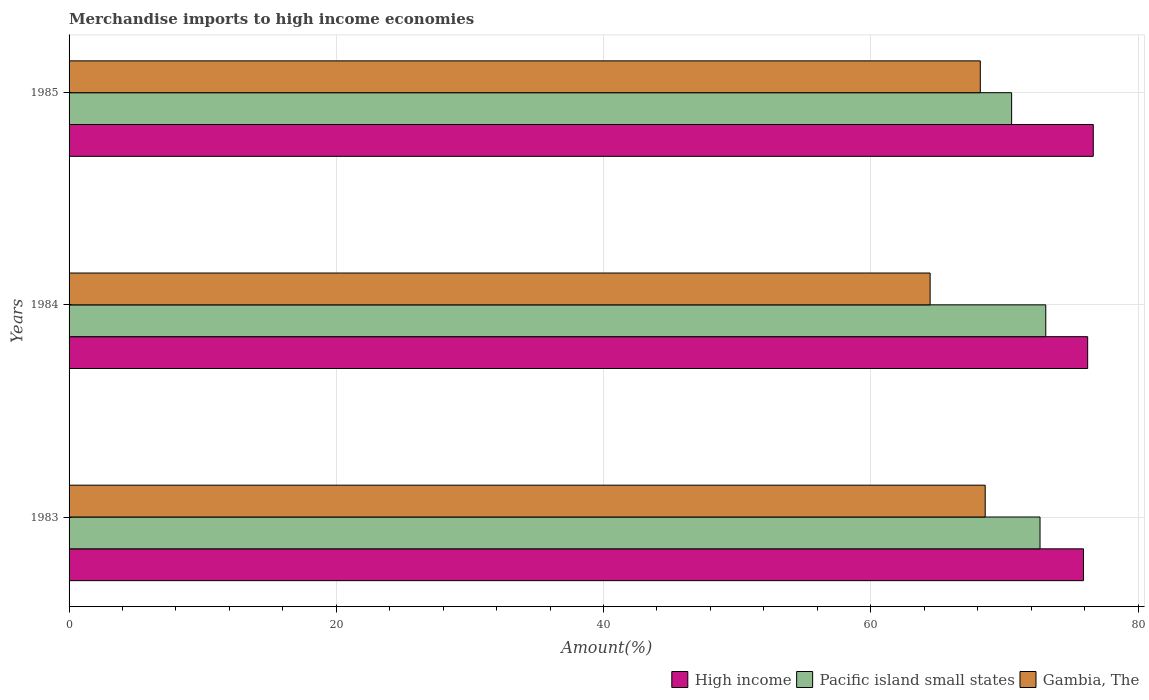How many groups of bars are there?
Give a very brief answer. 3. In how many cases, is the number of bars for a given year not equal to the number of legend labels?
Keep it short and to the point. 0. What is the percentage of amount earned from merchandise imports in High income in 1983?
Make the answer very short. 75.92. Across all years, what is the maximum percentage of amount earned from merchandise imports in Pacific island small states?
Your answer should be compact. 73.1. Across all years, what is the minimum percentage of amount earned from merchandise imports in High income?
Ensure brevity in your answer.  75.92. In which year was the percentage of amount earned from merchandise imports in High income minimum?
Offer a terse response. 1983. What is the total percentage of amount earned from merchandise imports in Gambia, The in the graph?
Provide a succinct answer. 201.2. What is the difference between the percentage of amount earned from merchandise imports in Gambia, The in 1983 and that in 1984?
Ensure brevity in your answer.  4.12. What is the difference between the percentage of amount earned from merchandise imports in Gambia, The in 1983 and the percentage of amount earned from merchandise imports in Pacific island small states in 1984?
Provide a short and direct response. -4.53. What is the average percentage of amount earned from merchandise imports in Pacific island small states per year?
Offer a terse response. 72.1. In the year 1983, what is the difference between the percentage of amount earned from merchandise imports in High income and percentage of amount earned from merchandise imports in Pacific island small states?
Offer a very short reply. 3.25. In how many years, is the percentage of amount earned from merchandise imports in High income greater than 8 %?
Offer a very short reply. 3. What is the ratio of the percentage of amount earned from merchandise imports in Gambia, The in 1984 to that in 1985?
Keep it short and to the point. 0.94. Is the percentage of amount earned from merchandise imports in Pacific island small states in 1983 less than that in 1985?
Your answer should be compact. No. Is the difference between the percentage of amount earned from merchandise imports in High income in 1983 and 1985 greater than the difference between the percentage of amount earned from merchandise imports in Pacific island small states in 1983 and 1985?
Your answer should be very brief. No. What is the difference between the highest and the second highest percentage of amount earned from merchandise imports in High income?
Your response must be concise. 0.42. What is the difference between the highest and the lowest percentage of amount earned from merchandise imports in Gambia, The?
Keep it short and to the point. 4.12. In how many years, is the percentage of amount earned from merchandise imports in Pacific island small states greater than the average percentage of amount earned from merchandise imports in Pacific island small states taken over all years?
Keep it short and to the point. 2. What does the 1st bar from the top in 1984 represents?
Ensure brevity in your answer.  Gambia, The. What does the 3rd bar from the bottom in 1984 represents?
Provide a short and direct response. Gambia, The. How many bars are there?
Provide a succinct answer. 9. How many years are there in the graph?
Your response must be concise. 3. Does the graph contain any zero values?
Keep it short and to the point. No. Does the graph contain grids?
Offer a terse response. Yes. What is the title of the graph?
Provide a short and direct response. Merchandise imports to high income economies. Does "Micronesia" appear as one of the legend labels in the graph?
Your answer should be very brief. No. What is the label or title of the X-axis?
Make the answer very short. Amount(%). What is the Amount(%) in High income in 1983?
Your response must be concise. 75.92. What is the Amount(%) in Pacific island small states in 1983?
Your answer should be compact. 72.67. What is the Amount(%) in Gambia, The in 1983?
Offer a very short reply. 68.56. What is the Amount(%) in High income in 1984?
Your answer should be compact. 76.23. What is the Amount(%) in Pacific island small states in 1984?
Your response must be concise. 73.1. What is the Amount(%) of Gambia, The in 1984?
Give a very brief answer. 64.44. What is the Amount(%) in High income in 1985?
Offer a very short reply. 76.65. What is the Amount(%) in Pacific island small states in 1985?
Your answer should be compact. 70.54. What is the Amount(%) of Gambia, The in 1985?
Provide a succinct answer. 68.2. Across all years, what is the maximum Amount(%) in High income?
Offer a terse response. 76.65. Across all years, what is the maximum Amount(%) in Pacific island small states?
Provide a short and direct response. 73.1. Across all years, what is the maximum Amount(%) of Gambia, The?
Provide a succinct answer. 68.56. Across all years, what is the minimum Amount(%) of High income?
Your response must be concise. 75.92. Across all years, what is the minimum Amount(%) in Pacific island small states?
Make the answer very short. 70.54. Across all years, what is the minimum Amount(%) of Gambia, The?
Keep it short and to the point. 64.44. What is the total Amount(%) in High income in the graph?
Ensure brevity in your answer.  228.8. What is the total Amount(%) of Pacific island small states in the graph?
Your response must be concise. 216.3. What is the total Amount(%) in Gambia, The in the graph?
Ensure brevity in your answer.  201.2. What is the difference between the Amount(%) in High income in 1983 and that in 1984?
Give a very brief answer. -0.31. What is the difference between the Amount(%) in Pacific island small states in 1983 and that in 1984?
Offer a terse response. -0.43. What is the difference between the Amount(%) of Gambia, The in 1983 and that in 1984?
Ensure brevity in your answer.  4.12. What is the difference between the Amount(%) in High income in 1983 and that in 1985?
Your response must be concise. -0.73. What is the difference between the Amount(%) in Pacific island small states in 1983 and that in 1985?
Offer a very short reply. 2.13. What is the difference between the Amount(%) in Gambia, The in 1983 and that in 1985?
Your response must be concise. 0.37. What is the difference between the Amount(%) of High income in 1984 and that in 1985?
Provide a succinct answer. -0.42. What is the difference between the Amount(%) in Pacific island small states in 1984 and that in 1985?
Your answer should be compact. 2.56. What is the difference between the Amount(%) of Gambia, The in 1984 and that in 1985?
Your answer should be very brief. -3.76. What is the difference between the Amount(%) in High income in 1983 and the Amount(%) in Pacific island small states in 1984?
Offer a terse response. 2.82. What is the difference between the Amount(%) in High income in 1983 and the Amount(%) in Gambia, The in 1984?
Your answer should be compact. 11.48. What is the difference between the Amount(%) in Pacific island small states in 1983 and the Amount(%) in Gambia, The in 1984?
Ensure brevity in your answer.  8.22. What is the difference between the Amount(%) of High income in 1983 and the Amount(%) of Pacific island small states in 1985?
Your answer should be very brief. 5.38. What is the difference between the Amount(%) in High income in 1983 and the Amount(%) in Gambia, The in 1985?
Provide a short and direct response. 7.72. What is the difference between the Amount(%) in Pacific island small states in 1983 and the Amount(%) in Gambia, The in 1985?
Offer a very short reply. 4.47. What is the difference between the Amount(%) in High income in 1984 and the Amount(%) in Pacific island small states in 1985?
Give a very brief answer. 5.69. What is the difference between the Amount(%) in High income in 1984 and the Amount(%) in Gambia, The in 1985?
Give a very brief answer. 8.04. What is the difference between the Amount(%) in Pacific island small states in 1984 and the Amount(%) in Gambia, The in 1985?
Offer a terse response. 4.9. What is the average Amount(%) in High income per year?
Your response must be concise. 76.27. What is the average Amount(%) of Pacific island small states per year?
Ensure brevity in your answer.  72.1. What is the average Amount(%) in Gambia, The per year?
Offer a terse response. 67.07. In the year 1983, what is the difference between the Amount(%) of High income and Amount(%) of Pacific island small states?
Offer a very short reply. 3.25. In the year 1983, what is the difference between the Amount(%) in High income and Amount(%) in Gambia, The?
Provide a short and direct response. 7.35. In the year 1983, what is the difference between the Amount(%) of Pacific island small states and Amount(%) of Gambia, The?
Your response must be concise. 4.1. In the year 1984, what is the difference between the Amount(%) in High income and Amount(%) in Pacific island small states?
Give a very brief answer. 3.14. In the year 1984, what is the difference between the Amount(%) of High income and Amount(%) of Gambia, The?
Your response must be concise. 11.79. In the year 1984, what is the difference between the Amount(%) in Pacific island small states and Amount(%) in Gambia, The?
Ensure brevity in your answer.  8.65. In the year 1985, what is the difference between the Amount(%) of High income and Amount(%) of Pacific island small states?
Ensure brevity in your answer.  6.11. In the year 1985, what is the difference between the Amount(%) of High income and Amount(%) of Gambia, The?
Provide a short and direct response. 8.46. In the year 1985, what is the difference between the Amount(%) of Pacific island small states and Amount(%) of Gambia, The?
Your answer should be compact. 2.34. What is the ratio of the Amount(%) of High income in 1983 to that in 1984?
Ensure brevity in your answer.  1. What is the ratio of the Amount(%) of Gambia, The in 1983 to that in 1984?
Provide a succinct answer. 1.06. What is the ratio of the Amount(%) in High income in 1983 to that in 1985?
Offer a very short reply. 0.99. What is the ratio of the Amount(%) in Pacific island small states in 1983 to that in 1985?
Ensure brevity in your answer.  1.03. What is the ratio of the Amount(%) of Gambia, The in 1983 to that in 1985?
Offer a terse response. 1.01. What is the ratio of the Amount(%) in High income in 1984 to that in 1985?
Keep it short and to the point. 0.99. What is the ratio of the Amount(%) of Pacific island small states in 1984 to that in 1985?
Provide a succinct answer. 1.04. What is the ratio of the Amount(%) of Gambia, The in 1984 to that in 1985?
Offer a terse response. 0.94. What is the difference between the highest and the second highest Amount(%) of High income?
Give a very brief answer. 0.42. What is the difference between the highest and the second highest Amount(%) of Pacific island small states?
Keep it short and to the point. 0.43. What is the difference between the highest and the second highest Amount(%) of Gambia, The?
Offer a very short reply. 0.37. What is the difference between the highest and the lowest Amount(%) of High income?
Keep it short and to the point. 0.73. What is the difference between the highest and the lowest Amount(%) in Pacific island small states?
Ensure brevity in your answer.  2.56. What is the difference between the highest and the lowest Amount(%) of Gambia, The?
Your answer should be very brief. 4.12. 